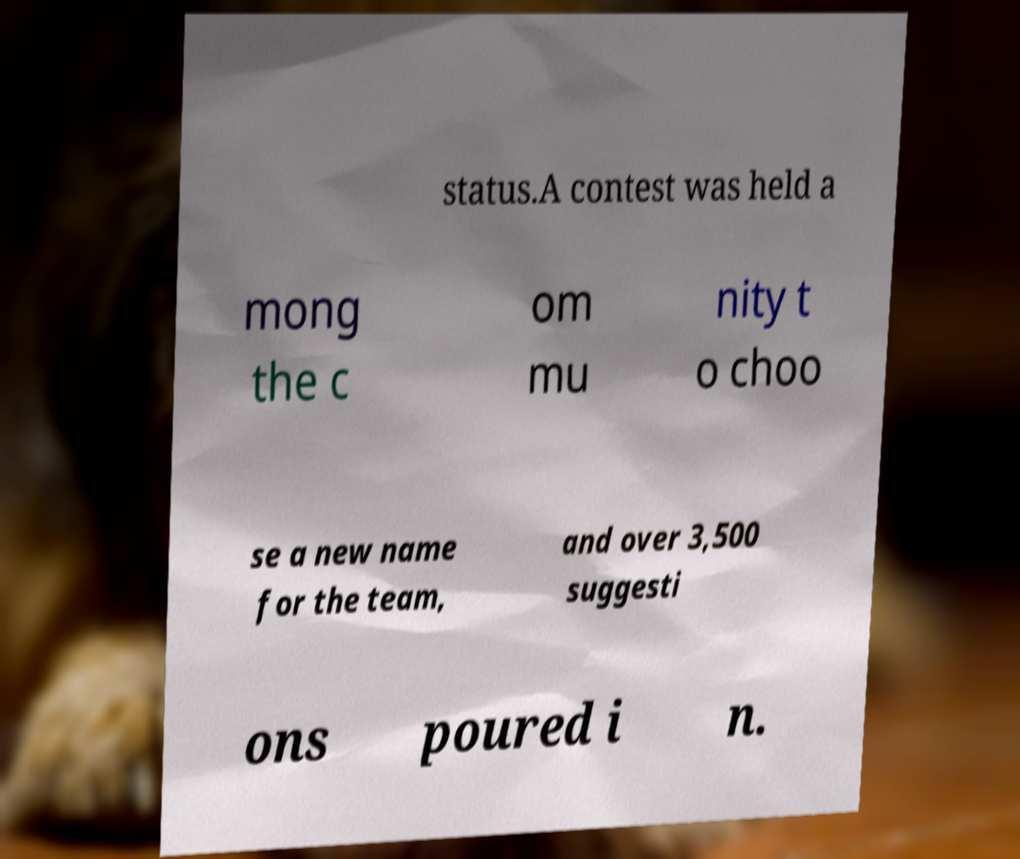Can you read and provide the text displayed in the image?This photo seems to have some interesting text. Can you extract and type it out for me? status.A contest was held a mong the c om mu nity t o choo se a new name for the team, and over 3,500 suggesti ons poured i n. 